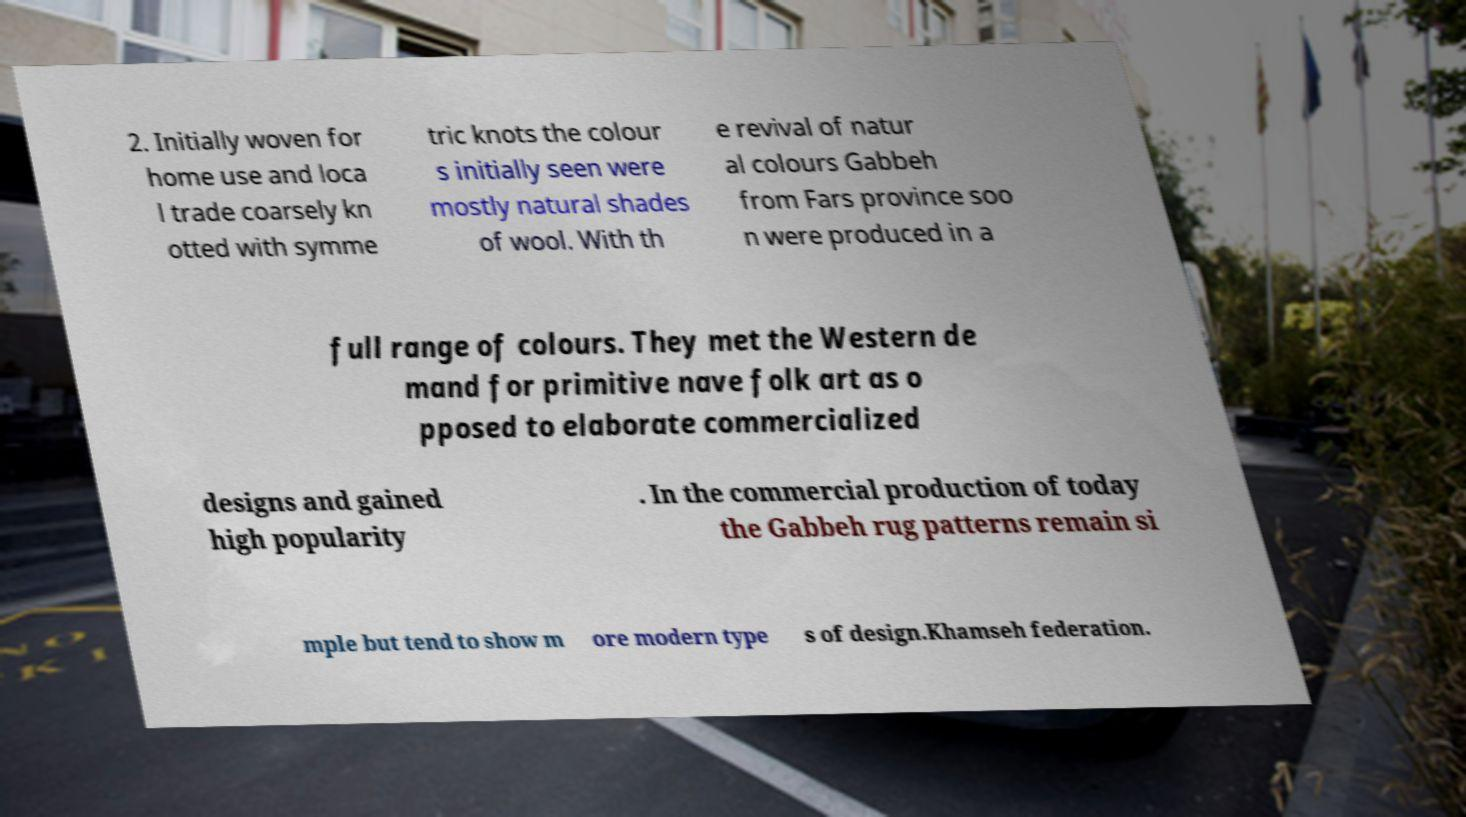Please identify and transcribe the text found in this image. 2. Initially woven for home use and loca l trade coarsely kn otted with symme tric knots the colour s initially seen were mostly natural shades of wool. With th e revival of natur al colours Gabbeh from Fars province soo n were produced in a full range of colours. They met the Western de mand for primitive nave folk art as o pposed to elaborate commercialized designs and gained high popularity . In the commercial production of today the Gabbeh rug patterns remain si mple but tend to show m ore modern type s of design.Khamseh federation. 